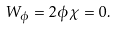<formula> <loc_0><loc_0><loc_500><loc_500>W _ { \phi } = 2 \phi \chi = 0 .</formula> 